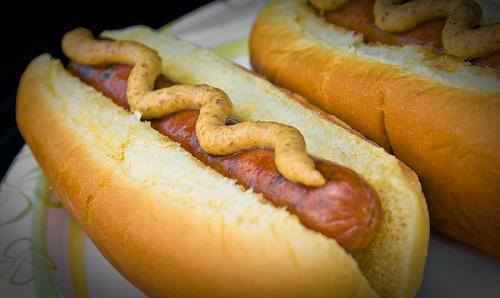Is this tasty?
Keep it brief. Yes. How many hot dogs are in the photo?
Short answer required. 2. What is yellow?
Keep it brief. Mustard. 